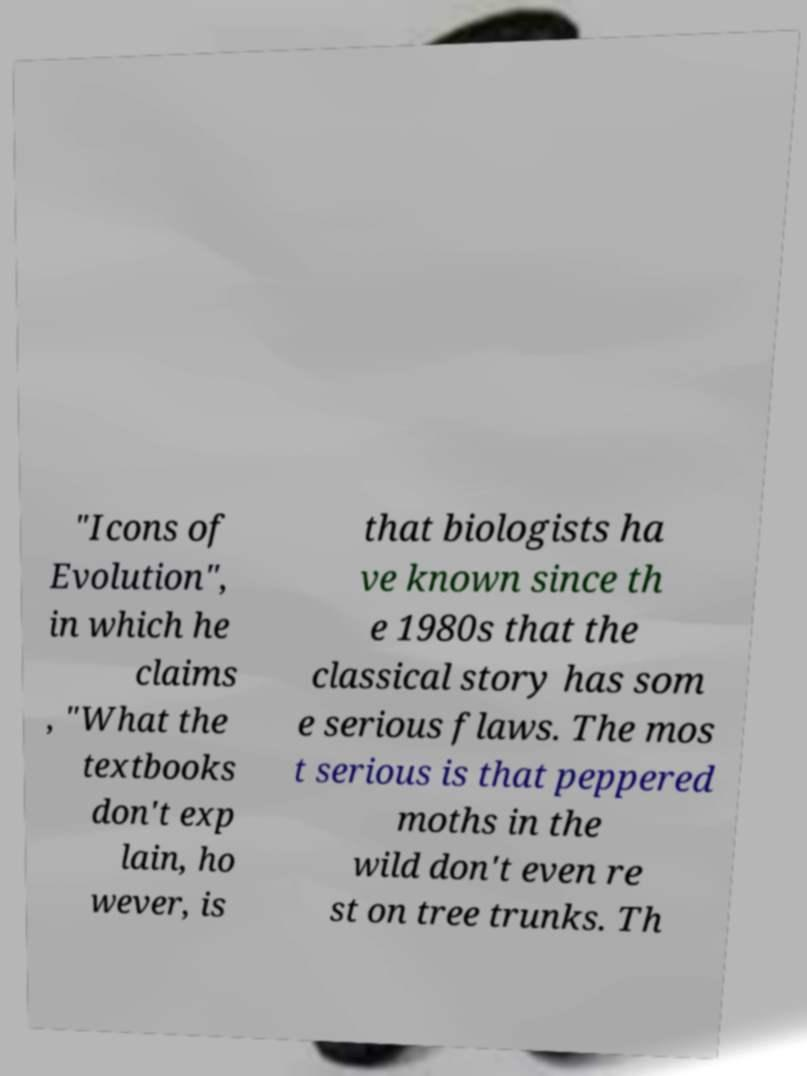What messages or text are displayed in this image? I need them in a readable, typed format. "Icons of Evolution", in which he claims , "What the textbooks don't exp lain, ho wever, is that biologists ha ve known since th e 1980s that the classical story has som e serious flaws. The mos t serious is that peppered moths in the wild don't even re st on tree trunks. Th 